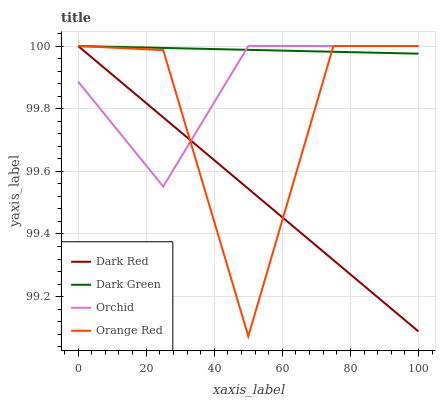Does Dark Red have the minimum area under the curve?
Answer yes or no. Yes. Does Dark Green have the maximum area under the curve?
Answer yes or no. Yes. Does Orchid have the minimum area under the curve?
Answer yes or no. No. Does Orchid have the maximum area under the curve?
Answer yes or no. No. Is Dark Red the smoothest?
Answer yes or no. Yes. Is Orange Red the roughest?
Answer yes or no. Yes. Is Orchid the smoothest?
Answer yes or no. No. Is Orchid the roughest?
Answer yes or no. No. Does Orange Red have the lowest value?
Answer yes or no. Yes. Does Orchid have the lowest value?
Answer yes or no. No. Does Dark Green have the highest value?
Answer yes or no. Yes. Does Orchid intersect Dark Green?
Answer yes or no. Yes. Is Orchid less than Dark Green?
Answer yes or no. No. Is Orchid greater than Dark Green?
Answer yes or no. No. 